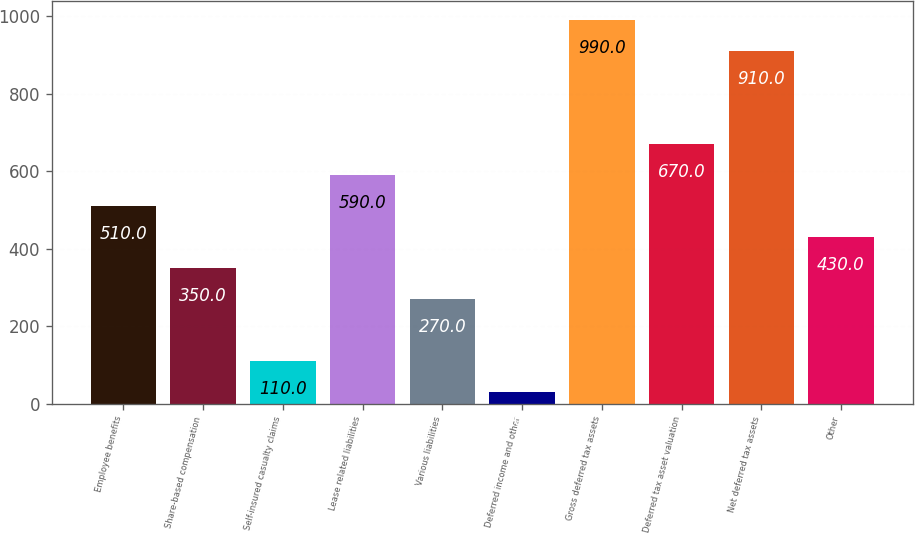Convert chart to OTSL. <chart><loc_0><loc_0><loc_500><loc_500><bar_chart><fcel>Employee benefits<fcel>Share-based compensation<fcel>Self-insured casualty claims<fcel>Lease related liabilities<fcel>Various liabilities<fcel>Deferred income and other<fcel>Gross deferred tax assets<fcel>Deferred tax asset valuation<fcel>Net deferred tax assets<fcel>Other<nl><fcel>510<fcel>350<fcel>110<fcel>590<fcel>270<fcel>30<fcel>990<fcel>670<fcel>910<fcel>430<nl></chart> 